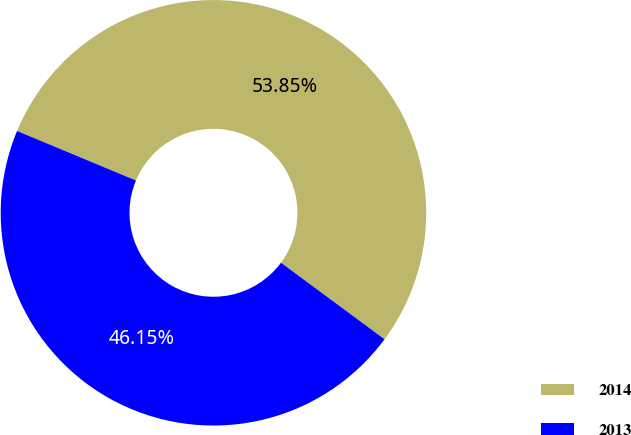<chart> <loc_0><loc_0><loc_500><loc_500><pie_chart><fcel>2014<fcel>2013<nl><fcel>53.85%<fcel>46.15%<nl></chart> 